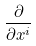Convert formula to latex. <formula><loc_0><loc_0><loc_500><loc_500>\frac { \partial } { \partial x ^ { i } }</formula> 